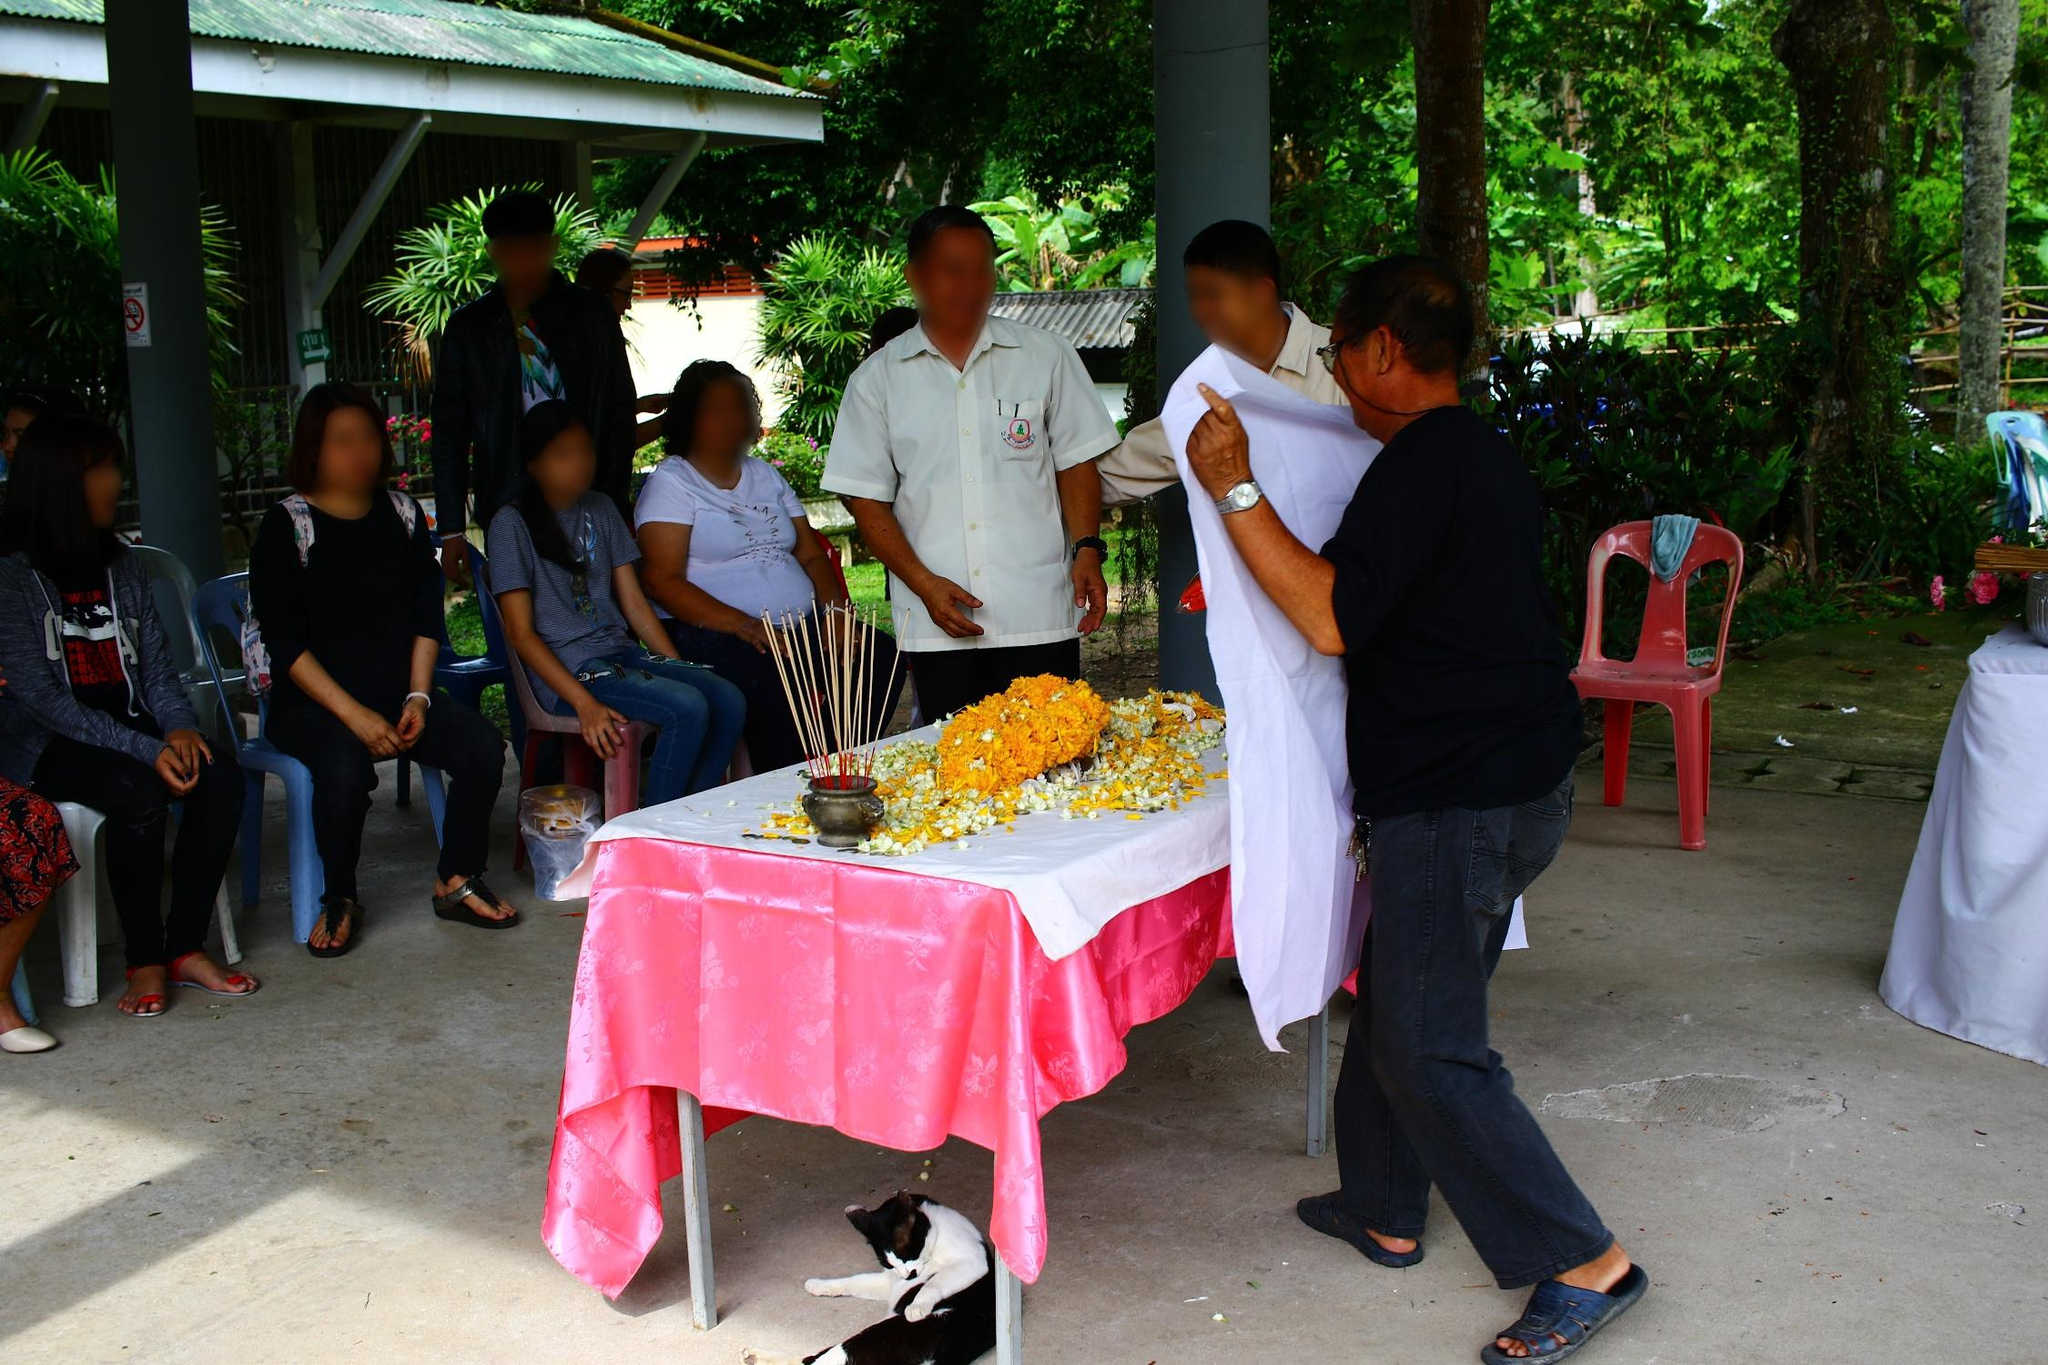What cultural or religious significance might the items on the table represent? The items on the table, particularly the marigold flowers and incense sticks, are commonly used in various Asian cultures for religious and spiritual ceremonies. Marigolds are often associated with honor and respect in death-related rituals, suggesting this gathering could be a commemoration or a respect-paying event. Incense sticks are used to purify the surroundings, ward off spirits, and bring forth positivity, playing a crucial role in setting a sacred or ceremonial ambiance. Are there any other details in the scene that support the idea of a memorial or commemorative event? Yes, several details support the idea of a ceremonial gathering, such as the white attire worn by one of the men, which is often symbolic of purity or mourning in many cultures. Additionally, the solemn expressions and gestures of respect, such as the man with a folded cloth (possibly a ceremonial shroud), suggest a reverence appropriate for memorial or commemorative rites. 